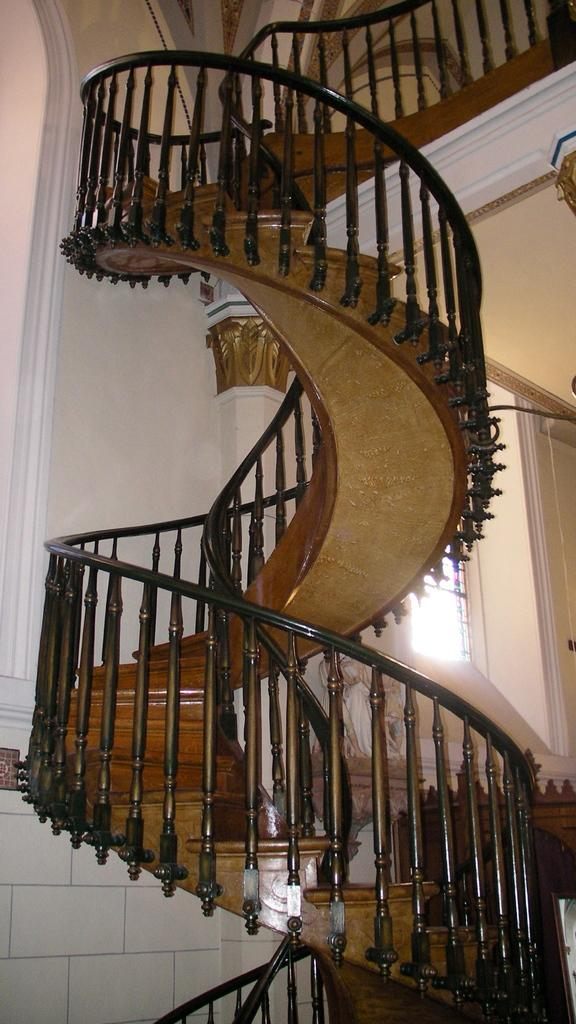What type of structure is present in the image? There are stairs in the image. What is the color of the stairs? The stairs are black in color. What can be seen in the background of the image? There is a wall in the background of the image. What is the color of the wall? The wall is white in color. Is there any opening in the wall visible in the image? Yes, there is a window visible in the image. Can you see any feathers floating near the stairs in the image? There are no feathers visible in the image. Are there any trains passing by in the image? There is no mention of trains in the image, only stairs and a wall with a window. 